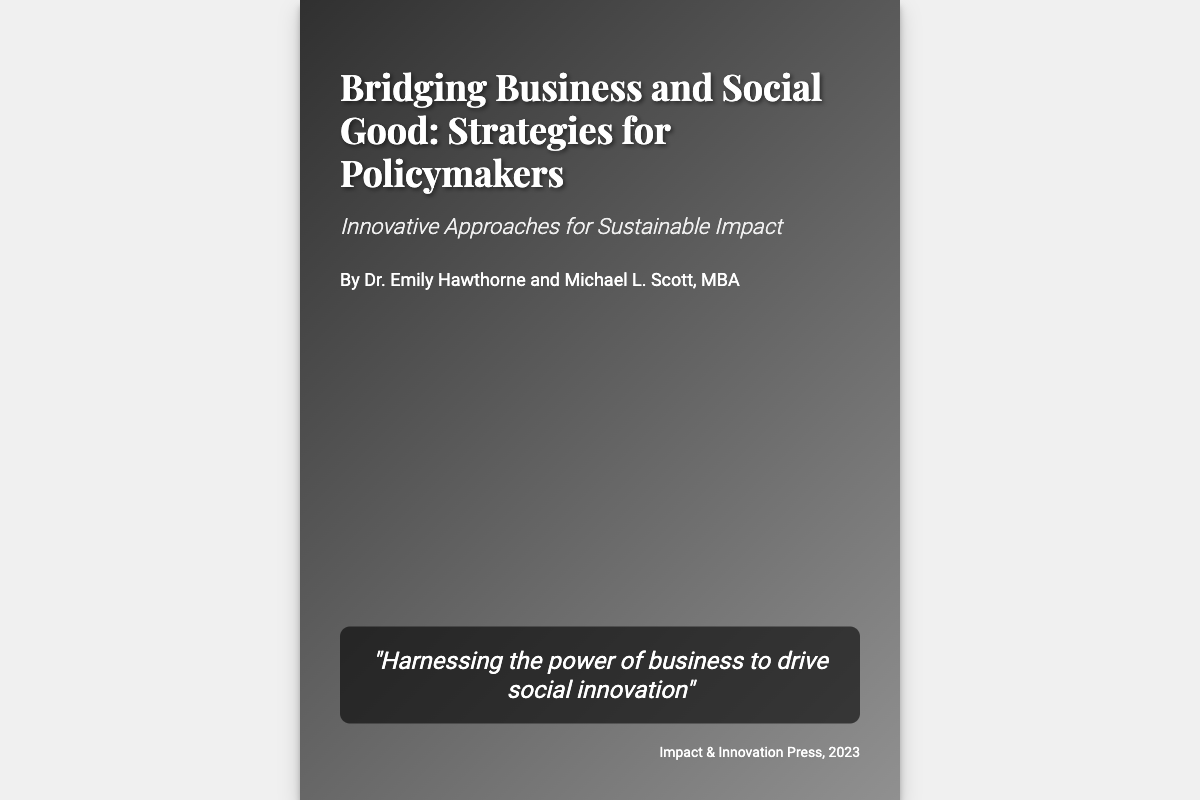What is the title of the book? The title of the book is presented prominently at the top of the cover.
Answer: Bridging Business and Social Good: Strategies for Policymakers Who are the authors of the book? The authors' names are listed beneath the subtitle on the cover.
Answer: Dr. Emily Hawthorne and Michael L. Scott, MBA What is the subtitle of the book? The subtitle provides additional context about the book's content, located under the title.
Answer: Innovative Approaches for Sustainable Impact What is the publisher's name? The publisher's name is mentioned at the bottom of the cover, indicating who produced the book.
Answer: Impact & Innovation Press In what year was the book published? The publication year can be found right next to the publisher's name.
Answer: 2023 What is the quote featured on the cover? A quote is included as an inspirational element in the design of the cover.
Answer: "Harnessing the power of business to drive social innovation" How large is the book cover? The size of the book cover is indicated in the document description.
Answer: 600px by 800px What design element enhances the text visibility on the cover? This element serves to improve the readability of text against the background of the cover.
Answer: Overlay with gradient What type of approaches does the book discuss? This refers to the methods or strategies the book emphasizes for effecting change.
Answer: Innovative Approaches 